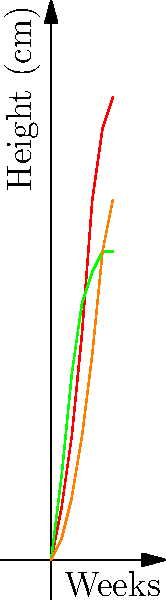Based on the growth patterns shown in the coordinate system, which plant exhibits the fastest initial growth rate but reaches its maximum height earliest? To answer this question, we need to analyze the growth patterns of each plant:

1. Tomato (red line):
   - Steady growth throughout the 6-week period
   - Reaches about 45 cm at week 6
   - Does not show signs of slowing down

2. Lettuce (green line):
   - Rapid initial growth in the first 3 weeks
   - Growth rate slows down after week 3
   - Reaches its maximum height of about 30 cm at week 5
   - Shows a plateau from week 5 to 6

3. Carrot (orange line):
   - Slow initial growth
   - Growth rate increases after week 3
   - Reaches about 35 cm at week 6
   - Does not show signs of slowing down

Comparing these patterns, we can see that lettuce has the steepest slope in the first 3 weeks, indicating the fastest initial growth rate. It also reaches its maximum height earliest, showing a plateau from week 5 to 6.

Therefore, lettuce exhibits both the fastest initial growth rate and reaches its maximum height earliest among the three plants.
Answer: Lettuce 